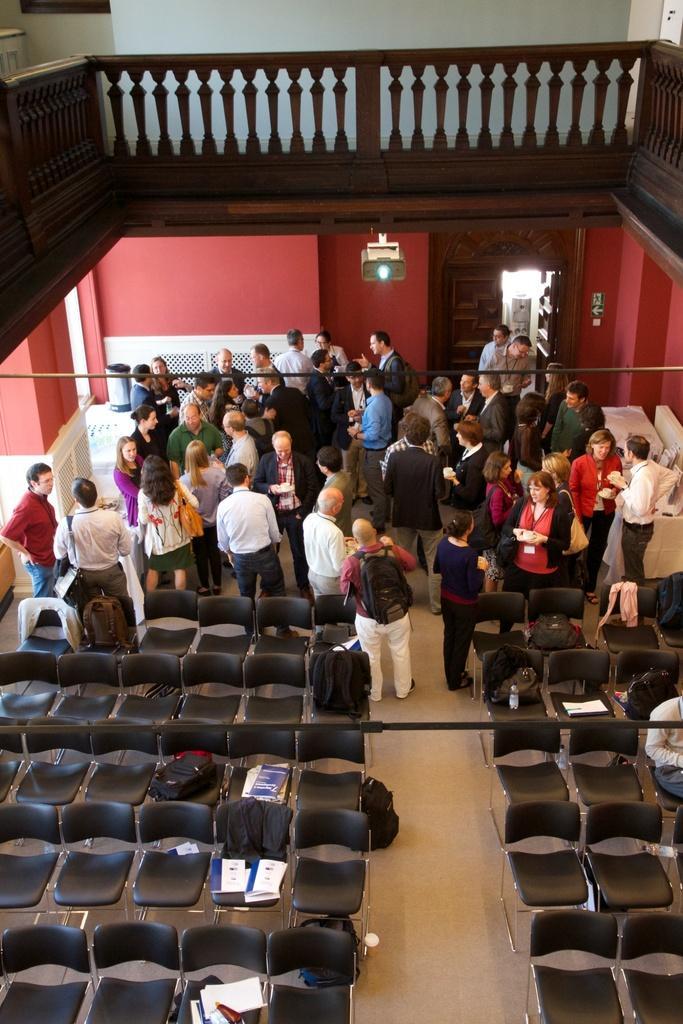Could you give a brief overview of what you see in this image? There are group of people standing and there are black chairs left empty behind them. 